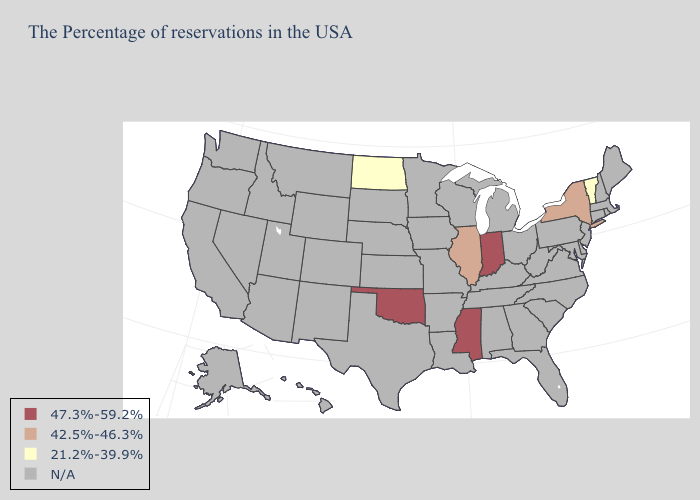What is the lowest value in states that border Wisconsin?
Concise answer only. 42.5%-46.3%. Name the states that have a value in the range 47.3%-59.2%?
Concise answer only. Indiana, Mississippi, Oklahoma. Is the legend a continuous bar?
Write a very short answer. No. What is the value of Montana?
Answer briefly. N/A. Name the states that have a value in the range 21.2%-39.9%?
Be succinct. Vermont, North Dakota. Name the states that have a value in the range 21.2%-39.9%?
Be succinct. Vermont, North Dakota. Name the states that have a value in the range 21.2%-39.9%?
Write a very short answer. Vermont, North Dakota. Name the states that have a value in the range N/A?
Keep it brief. Maine, Massachusetts, Rhode Island, New Hampshire, Connecticut, New Jersey, Delaware, Maryland, Pennsylvania, Virginia, North Carolina, South Carolina, West Virginia, Ohio, Florida, Georgia, Michigan, Kentucky, Alabama, Tennessee, Wisconsin, Louisiana, Missouri, Arkansas, Minnesota, Iowa, Kansas, Nebraska, Texas, South Dakota, Wyoming, Colorado, New Mexico, Utah, Montana, Arizona, Idaho, Nevada, California, Washington, Oregon, Alaska, Hawaii. 